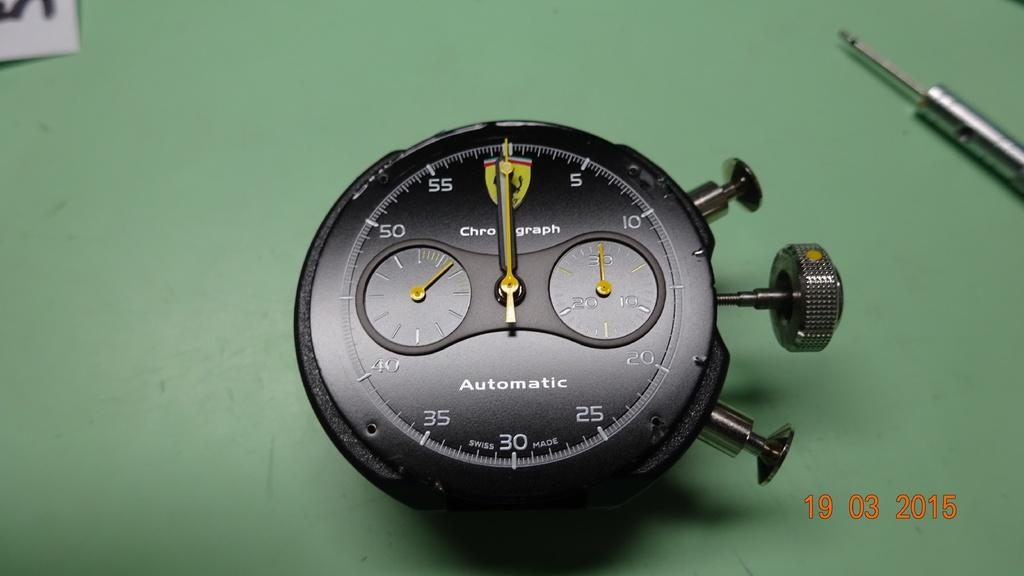What type of watch is in the image? There is an analog watch in the image. What color is the watch? The watch is black in color. What else can be seen in the image besides the watch? There is text written on the image. What type of string is attached to the edge of the watch in the image? There is no string attached to the watch in the image; it is an analog watch with no visible strings. 